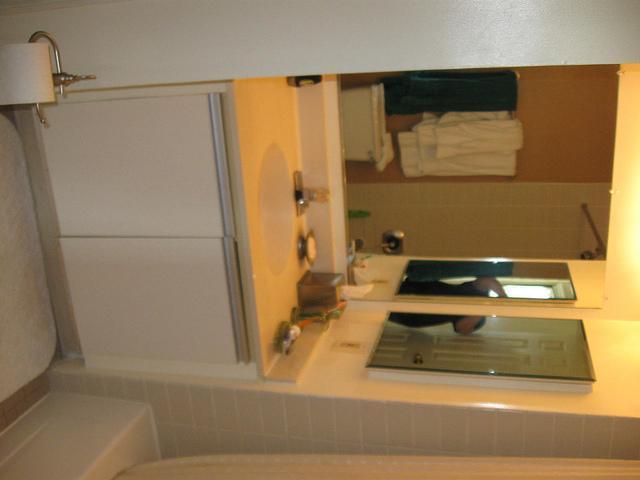How many mirrors are there?
Give a very brief answer. 2. 